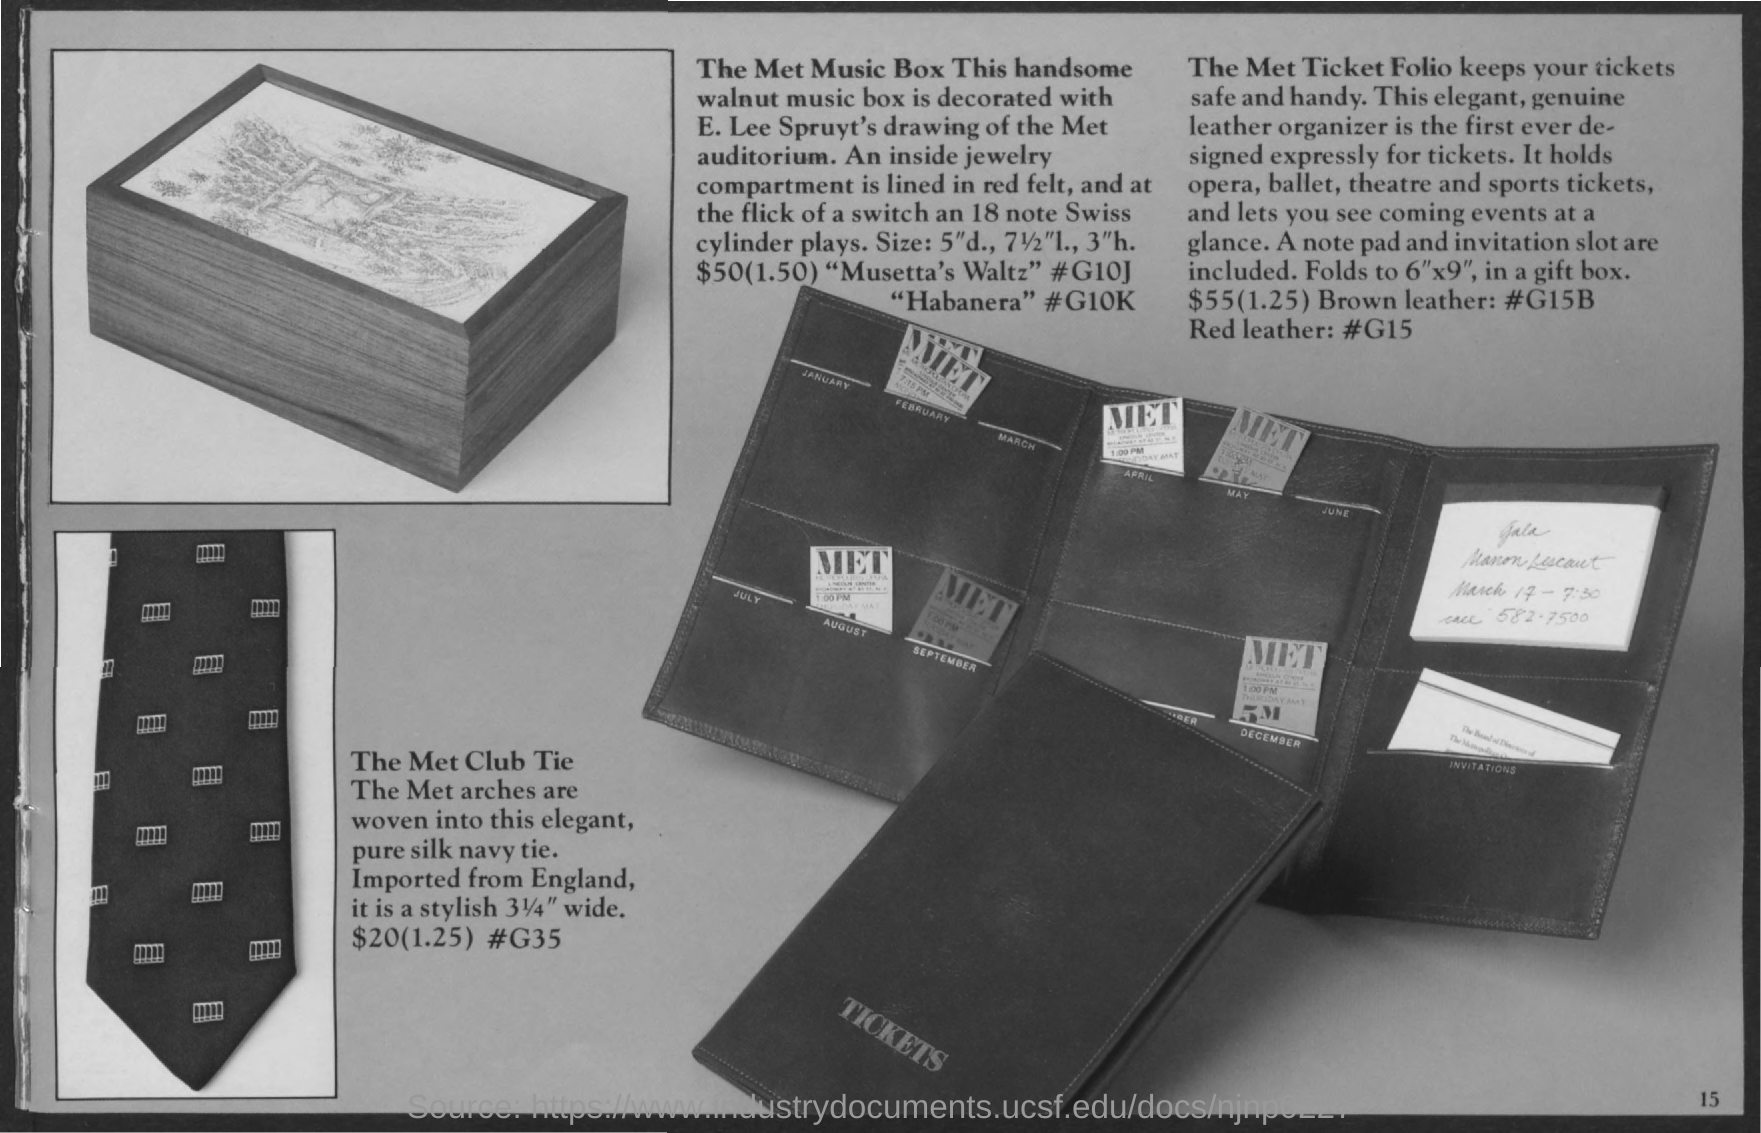List a handful of essential elements in this visual. The Met ticket folio safeguards and keeps the tickets readily accessible. The walnut music box is adorned with a rendering of the Metropolitan Opera House auditorium created by E. Lee Spruyt. 